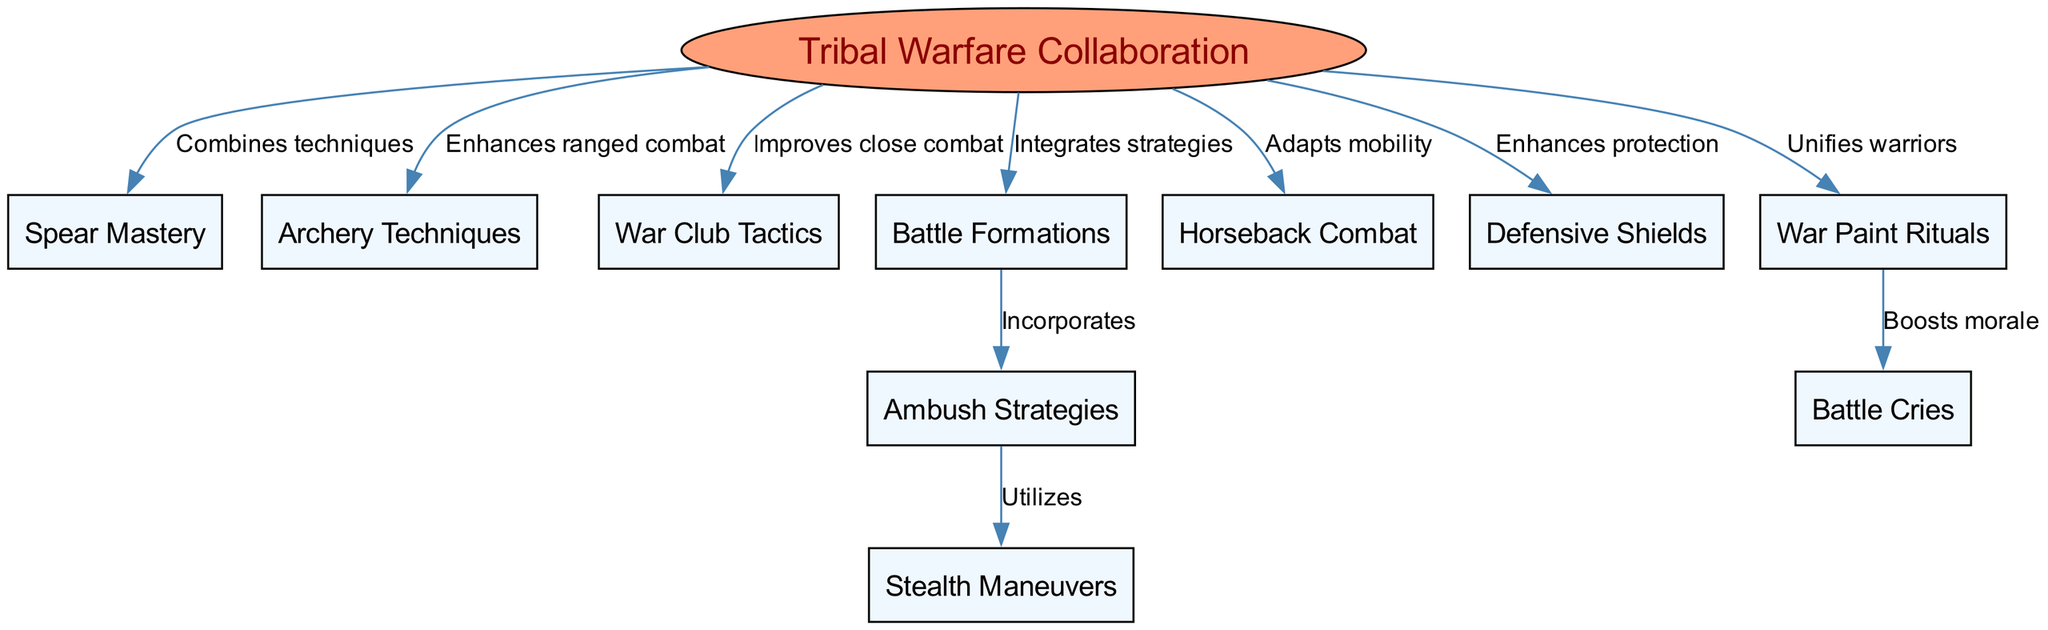What is the central concept of the diagram? The central concept is explicitly stated in the diagram as "Tribal Warfare Collaboration," making it the focal point around which other nodes are organized.
Answer: Tribal Warfare Collaboration How many nodes are there in total? By counting all the individual nodes listed in the diagram, including the central concept, we find that there are ten nodes in total: one central concept plus nine additional nodes.
Answer: 10 Which node enhances ranged combat? The node that directly connects to "Tribal Warfare Collaboration" indicating an enhancement to ranged combat is labeled "Archery Techniques."
Answer: Archery Techniques What relationship does Battle Formations have with Ambush Strategies? The diagram shows that "Battle Formations" incorporates "Ambush Strategies," meaning that ambush tactics are included as part of the formation strategies.
Answer: Incorporates Which node utilizes Stealth Maneuvers? The node "Ambush Strategies" is connected to "Stealth Maneuvers," indicating that ambush tactics specifically utilize stealth for their execution.
Answer: Utilizes What does War Paint Rituals do to Battle Cries? The connection between "War Paint Rituals" and "Battle Cries" indicates that war paint rituals boost the morale of the warriors, enhancing the effect of battle cries during combat.
Answer: Boosts morale How does Tribal Warfare Collaboration adapt mobility? The node "Horseback Combat" is connected to "Tribal Warfare Collaboration," which signifies that horseback combat methods are part of adapting mobility strategies in tribal warfare.
Answer: Adapts mobility What does Defensive Shields enhance? The label connecting "Defensive Shields" to "Tribal Warfare Collaboration" indicates that it enhances protection for the warriors participating in combat.
Answer: Enhances protection What is the connection between Spear Mastery and Tribal Warfare Collaboration? The diagram shows that "Spear Mastery" combines techniques with "Tribal Warfare Collaboration," implying that spear techniques are integrated into the collaborative combat strategies.
Answer: Combines techniques 